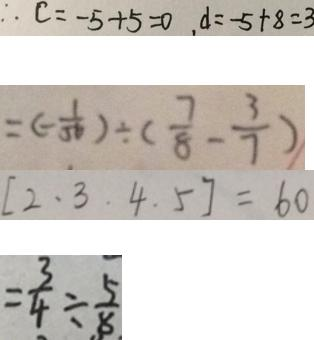<formula> <loc_0><loc_0><loc_500><loc_500>\therefore c = - 5 + 5 = 0 , d = - 5 + 8 = 3 
 = ( - \frac { 1 } { 5 6 } ) \div ( \frac { 7 } { 8 } - \frac { 3 } { 7 } ) 
 [ 2 . 3 . 4 . 5 ] = 6 0 
 = \frac { 3 } { 4 } \div \frac { 5 } { 8 }</formula> 